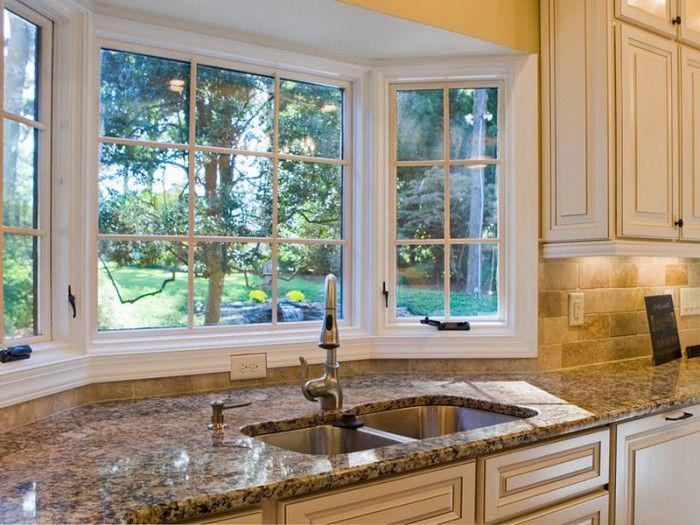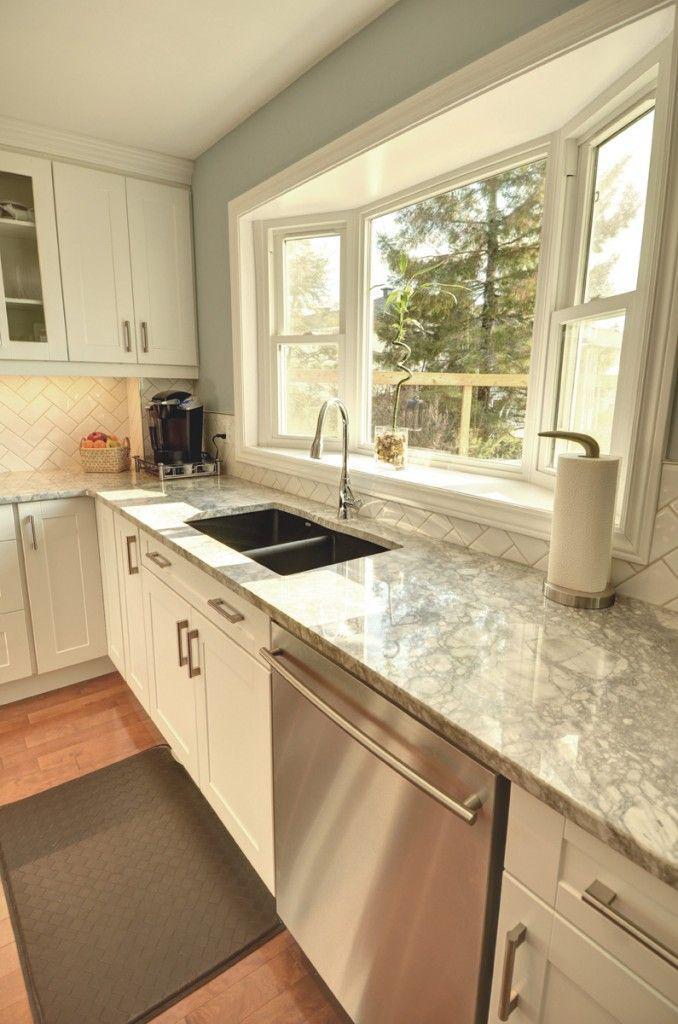The first image is the image on the left, the second image is the image on the right. Examine the images to the left and right. Is the description "Right image shows a bay window over a double sink in a white kitchen." accurate? Answer yes or no. Yes. 